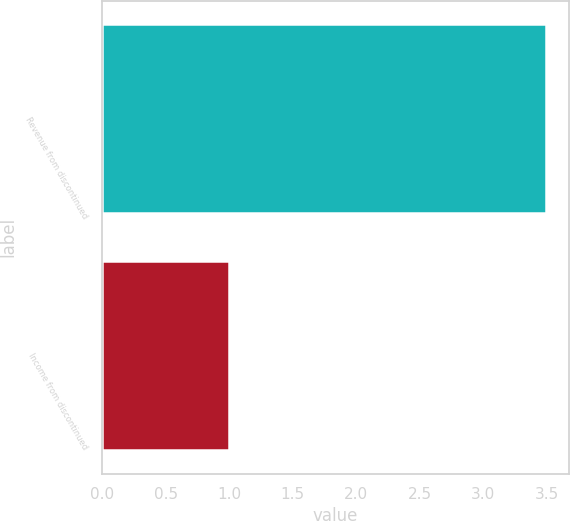<chart> <loc_0><loc_0><loc_500><loc_500><bar_chart><fcel>Revenue from discontinued<fcel>Income from discontinued<nl><fcel>3.5<fcel>1<nl></chart> 